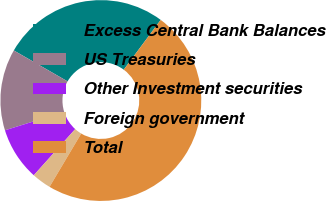Convert chart to OTSL. <chart><loc_0><loc_0><loc_500><loc_500><pie_chart><fcel>Excess Central Bank Balances<fcel>US Treasuries<fcel>Other Investment securities<fcel>Foreign government<fcel>Total<nl><fcel>26.86%<fcel>13.1%<fcel>8.57%<fcel>3.1%<fcel>48.38%<nl></chart> 